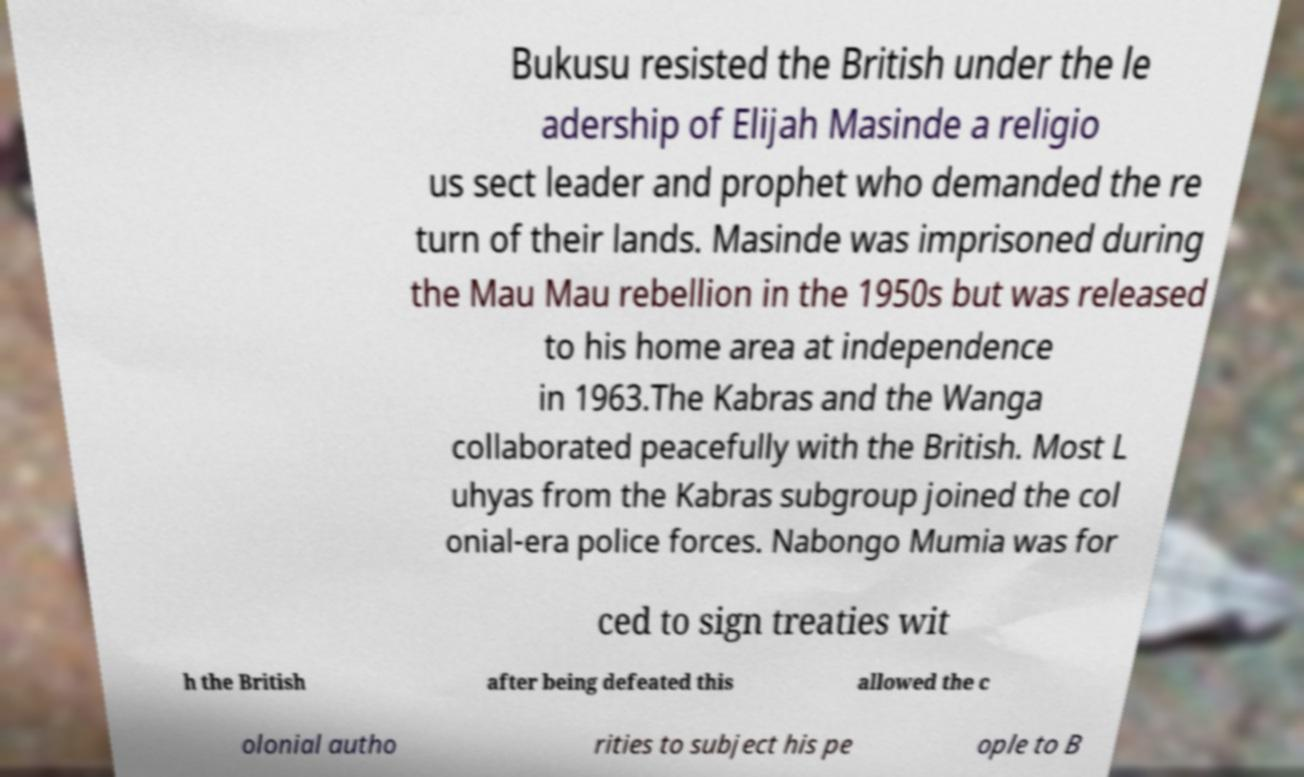Please identify and transcribe the text found in this image. Bukusu resisted the British under the le adership of Elijah Masinde a religio us sect leader and prophet who demanded the re turn of their lands. Masinde was imprisoned during the Mau Mau rebellion in the 1950s but was released to his home area at independence in 1963.The Kabras and the Wanga collaborated peacefully with the British. Most L uhyas from the Kabras subgroup joined the col onial-era police forces. Nabongo Mumia was for ced to sign treaties wit h the British after being defeated this allowed the c olonial autho rities to subject his pe ople to B 